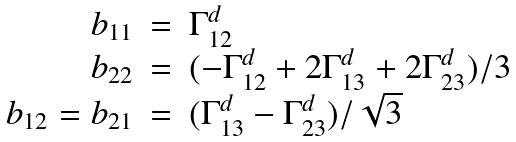Convert formula to latex. <formula><loc_0><loc_0><loc_500><loc_500>\begin{array} { r c l l } b _ { 1 1 } & = & \Gamma _ { 1 2 } ^ { d } \\ b _ { 2 2 } & = & ( - \Gamma _ { 1 2 } ^ { d } + 2 \Gamma _ { 1 3 } ^ { d } + 2 \Gamma _ { 2 3 } ^ { d } ) / 3 \\ b _ { 1 2 } = b _ { 2 1 } & = & ( \Gamma _ { 1 3 } ^ { d } - \Gamma _ { 2 3 } ^ { d } ) / \sqrt { 3 } \end{array}</formula> 